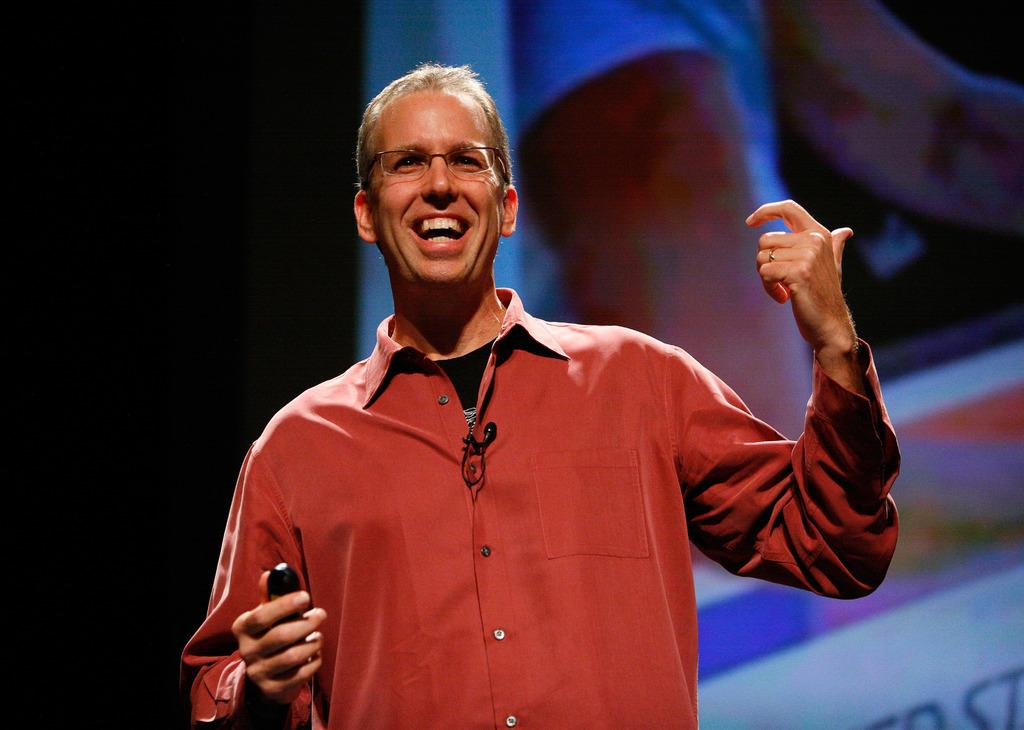What is the man in the image doing? The man is smiling in the image. What is the man holding in the image? The man is holding something in the image. Can you describe the man's appearance? The man is wearing spectacles in the image. What can be seen in the background of the image? There is a screen-like object in the background of the image. What type of ball is the man playing with in the image? There is no ball present in the image. 